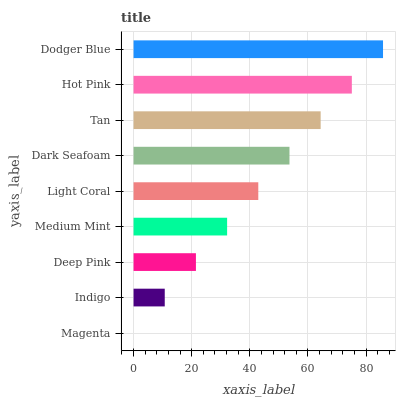Is Magenta the minimum?
Answer yes or no. Yes. Is Dodger Blue the maximum?
Answer yes or no. Yes. Is Indigo the minimum?
Answer yes or no. No. Is Indigo the maximum?
Answer yes or no. No. Is Indigo greater than Magenta?
Answer yes or no. Yes. Is Magenta less than Indigo?
Answer yes or no. Yes. Is Magenta greater than Indigo?
Answer yes or no. No. Is Indigo less than Magenta?
Answer yes or no. No. Is Light Coral the high median?
Answer yes or no. Yes. Is Light Coral the low median?
Answer yes or no. Yes. Is Magenta the high median?
Answer yes or no. No. Is Deep Pink the low median?
Answer yes or no. No. 